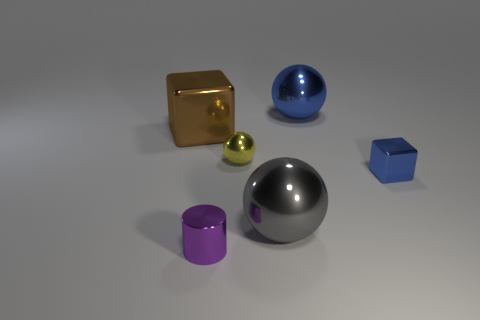Is there a big brown thing made of the same material as the gray ball?
Make the answer very short. Yes. What is the shape of the blue metal object that is in front of the big object on the left side of the tiny purple shiny object in front of the gray sphere?
Give a very brief answer. Cube. What material is the big blue sphere?
Your answer should be compact. Metal. The cylinder that is made of the same material as the gray thing is what color?
Make the answer very short. Purple. There is a big thing behind the large metallic block; is there a blue block that is behind it?
Give a very brief answer. No. What number of other things are there of the same shape as the gray metallic object?
Your response must be concise. 2. There is a blue thing that is behind the tiny metallic sphere; does it have the same shape as the metallic thing that is in front of the big gray metal sphere?
Make the answer very short. No. There is a ball left of the big gray thing that is in front of the tiny metal ball; how many cylinders are left of it?
Provide a short and direct response. 1. What color is the big block?
Your answer should be very brief. Brown. What number of other things are the same size as the blue shiny ball?
Your answer should be very brief. 2. 